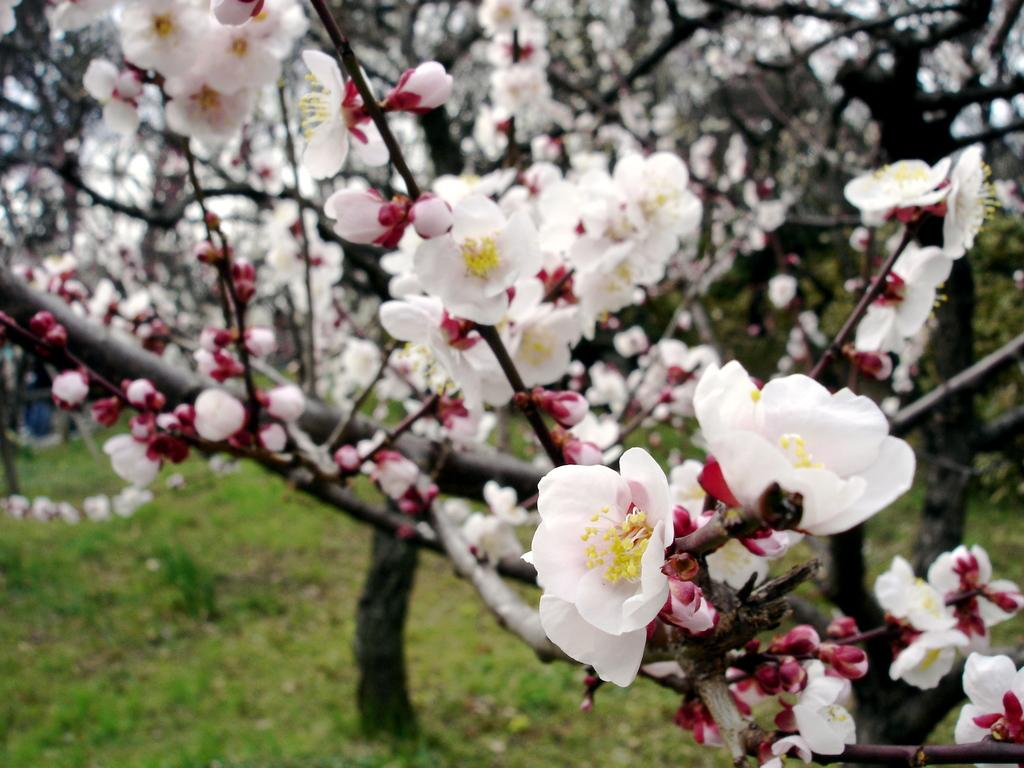What type of vegetation can be seen in the image? There are trees, grass, and flowers in the image. Can you describe the ground in the image? The ground is covered with grass in the image. What other elements can be seen in the image besides vegetation? There are no other elements mentioned in the provided facts. What type of throat lozenges are visible in the image? There are no throat lozenges present in the image. Can you tell me the brand of the calculator seen in the image? There is no calculator present in the image. 